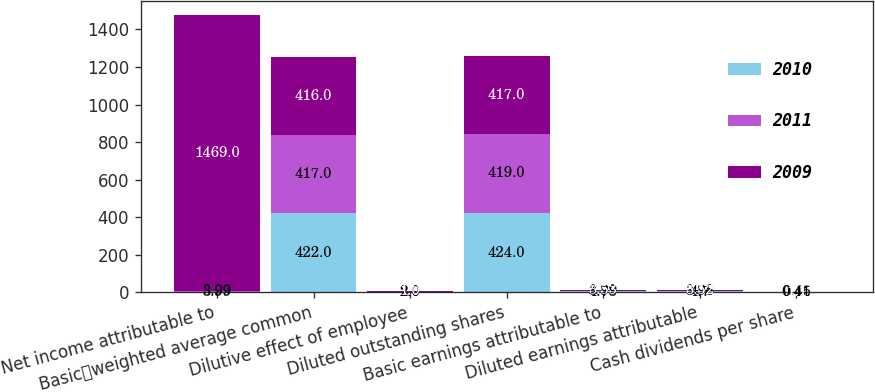<chart> <loc_0><loc_0><loc_500><loc_500><stacked_bar_chart><ecel><fcel>Net income attributable to<fcel>Basicweighted average common<fcel>Dilutive effect of employee<fcel>Diluted outstanding shares<fcel>Basic earnings attributable to<fcel>Diluted earnings attributable<fcel>Cash dividends per share<nl><fcel>2010<fcel>3.99<fcel>422<fcel>2<fcel>424<fcel>4.73<fcel>4.7<fcel>0.45<nl><fcel>2011<fcel>3.99<fcel>417<fcel>2<fcel>419<fcel>3.99<fcel>3.98<fcel>0.41<nl><fcel>2009<fcel>1469<fcel>416<fcel>1<fcel>417<fcel>3.53<fcel>3.52<fcel>1.1<nl></chart> 